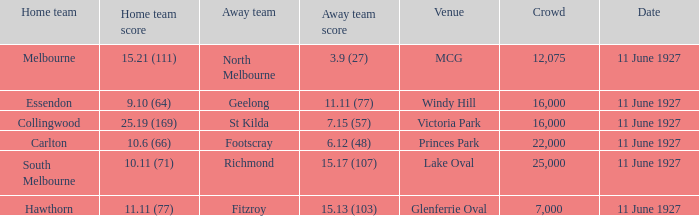What is the sum of all crowds present at the Glenferrie Oval venue? 7000.0. 